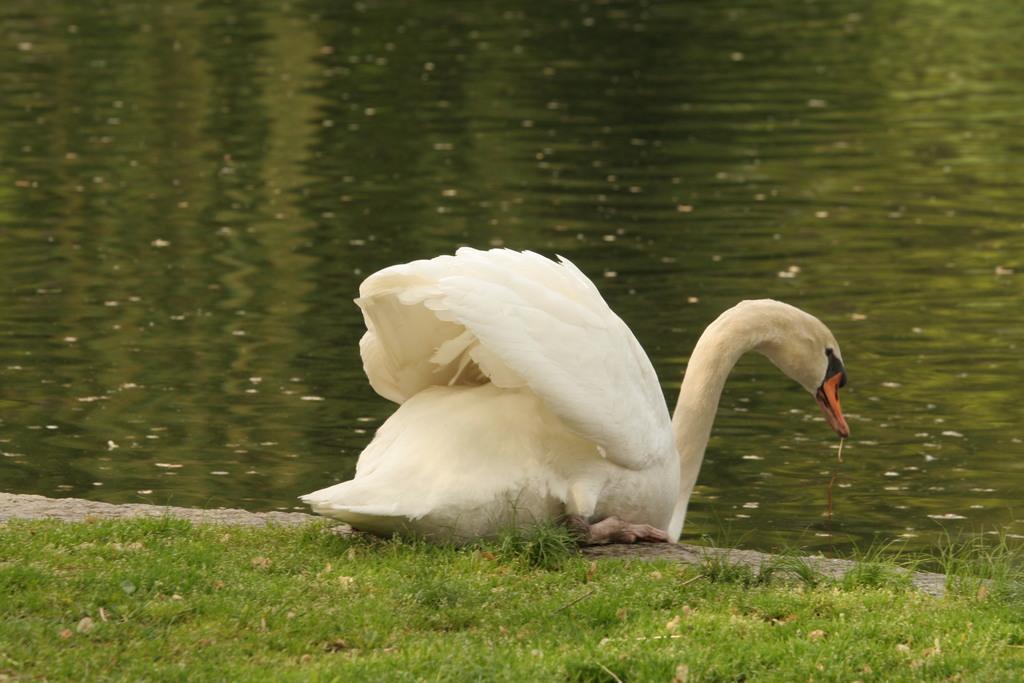How would you summarize this image in a sentence or two? In this image, we can see a swan. At the bottom, there is a grass. Background we can see water. 